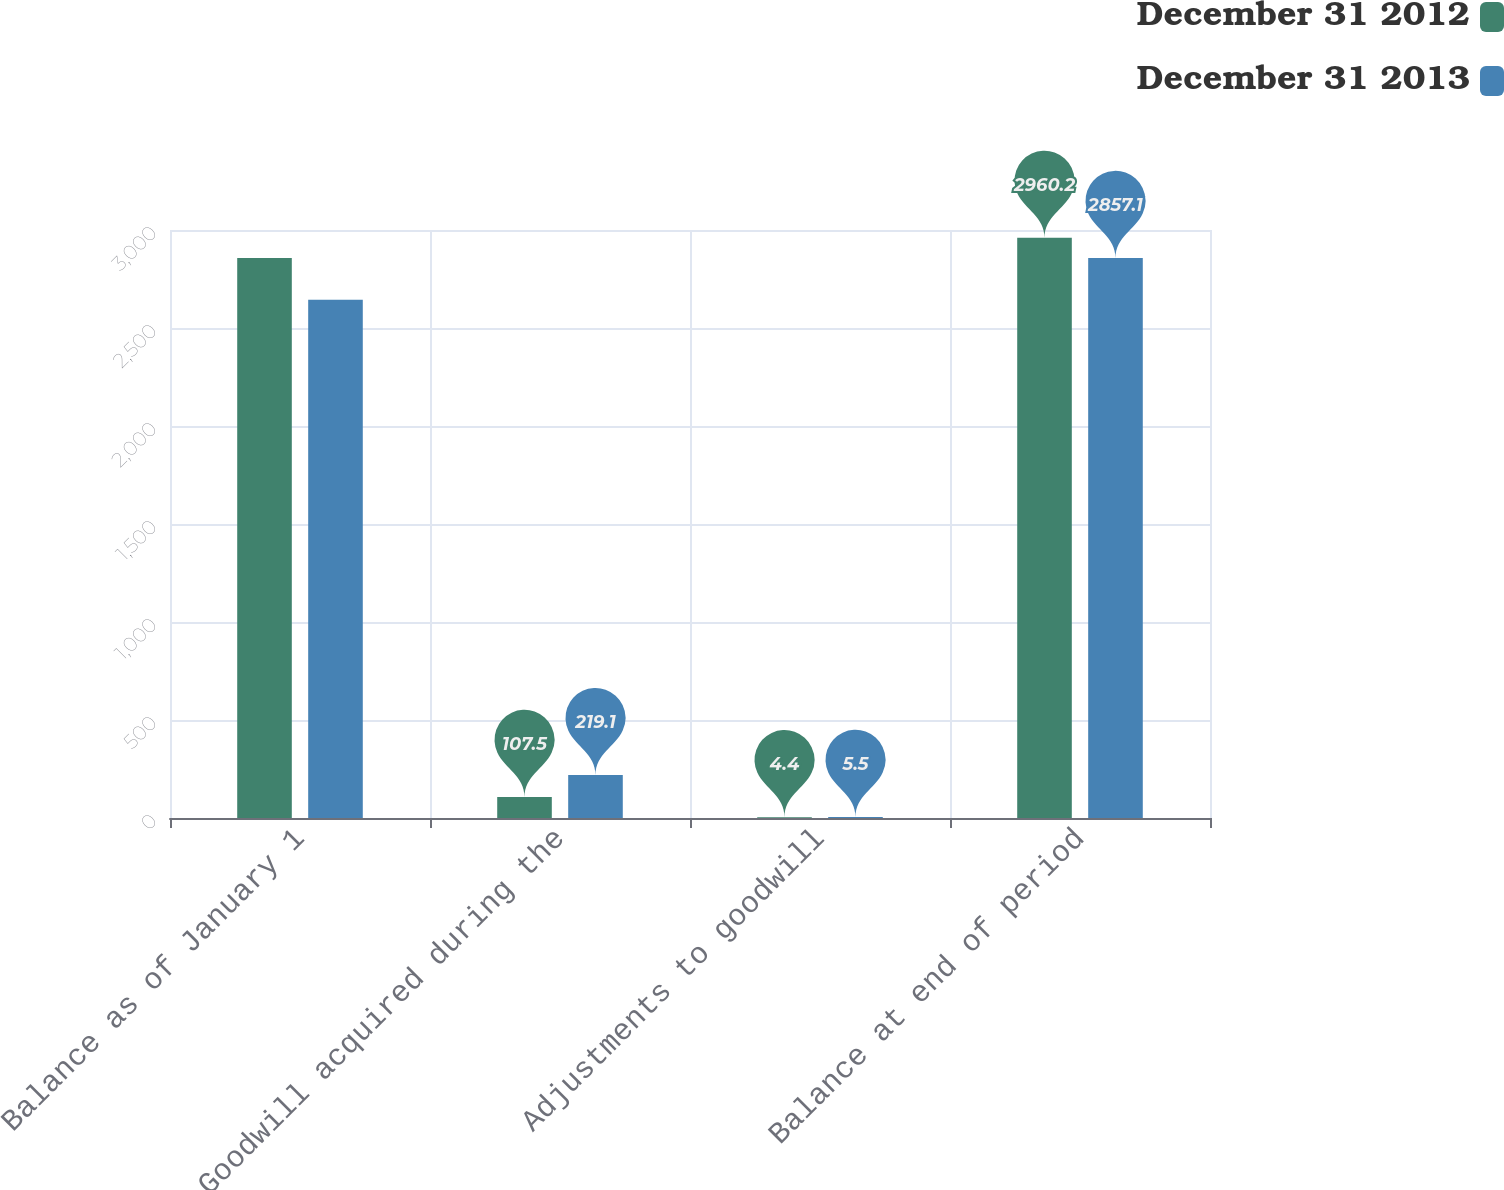Convert chart. <chart><loc_0><loc_0><loc_500><loc_500><stacked_bar_chart><ecel><fcel>Balance as of January 1<fcel>Goodwill acquired during the<fcel>Adjustments to goodwill<fcel>Balance at end of period<nl><fcel>December 31 2012<fcel>2857.1<fcel>107.5<fcel>4.4<fcel>2960.2<nl><fcel>December 31 2013<fcel>2643.5<fcel>219.1<fcel>5.5<fcel>2857.1<nl></chart> 